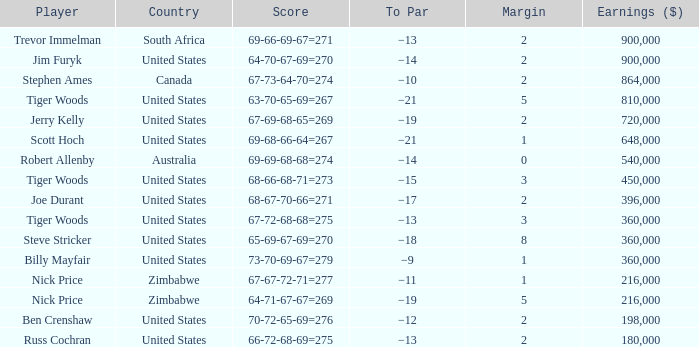For which to par, the earnings are more than $360,000, the year is after 1998, the country is the united states −21. Parse the full table. {'header': ['Player', 'Country', 'Score', 'To Par', 'Margin', 'Earnings ($)'], 'rows': [['Trevor Immelman', 'South Africa', '69-66-69-67=271', '−13', '2', '900,000'], ['Jim Furyk', 'United States', '64-70-67-69=270', '−14', '2', '900,000'], ['Stephen Ames', 'Canada', '67-73-64-70=274', '−10', '2', '864,000'], ['Tiger Woods', 'United States', '63-70-65-69=267', '−21', '5', '810,000'], ['Jerry Kelly', 'United States', '67-69-68-65=269', '−19', '2', '720,000'], ['Scott Hoch', 'United States', '69-68-66-64=267', '−21', '1', '648,000'], ['Robert Allenby', 'Australia', '69-69-68-68=274', '−14', '0', '540,000'], ['Tiger Woods', 'United States', '68-66-68-71=273', '−15', '3', '450,000'], ['Joe Durant', 'United States', '68-67-70-66=271', '−17', '2', '396,000'], ['Tiger Woods', 'United States', '67-72-68-68=275', '−13', '3', '360,000'], ['Steve Stricker', 'United States', '65-69-67-69=270', '−18', '8', '360,000'], ['Billy Mayfair', 'United States', '73-70-69-67=279', '−9', '1', '360,000'], ['Nick Price', 'Zimbabwe', '67-67-72-71=277', '−11', '1', '216,000'], ['Nick Price', 'Zimbabwe', '64-71-67-67=269', '−19', '5', '216,000'], ['Ben Crenshaw', 'United States', '70-72-65-69=276', '−12', '2', '198,000'], ['Russ Cochran', 'United States', '66-72-68-69=275', '−13', '2', '180,000']]} 